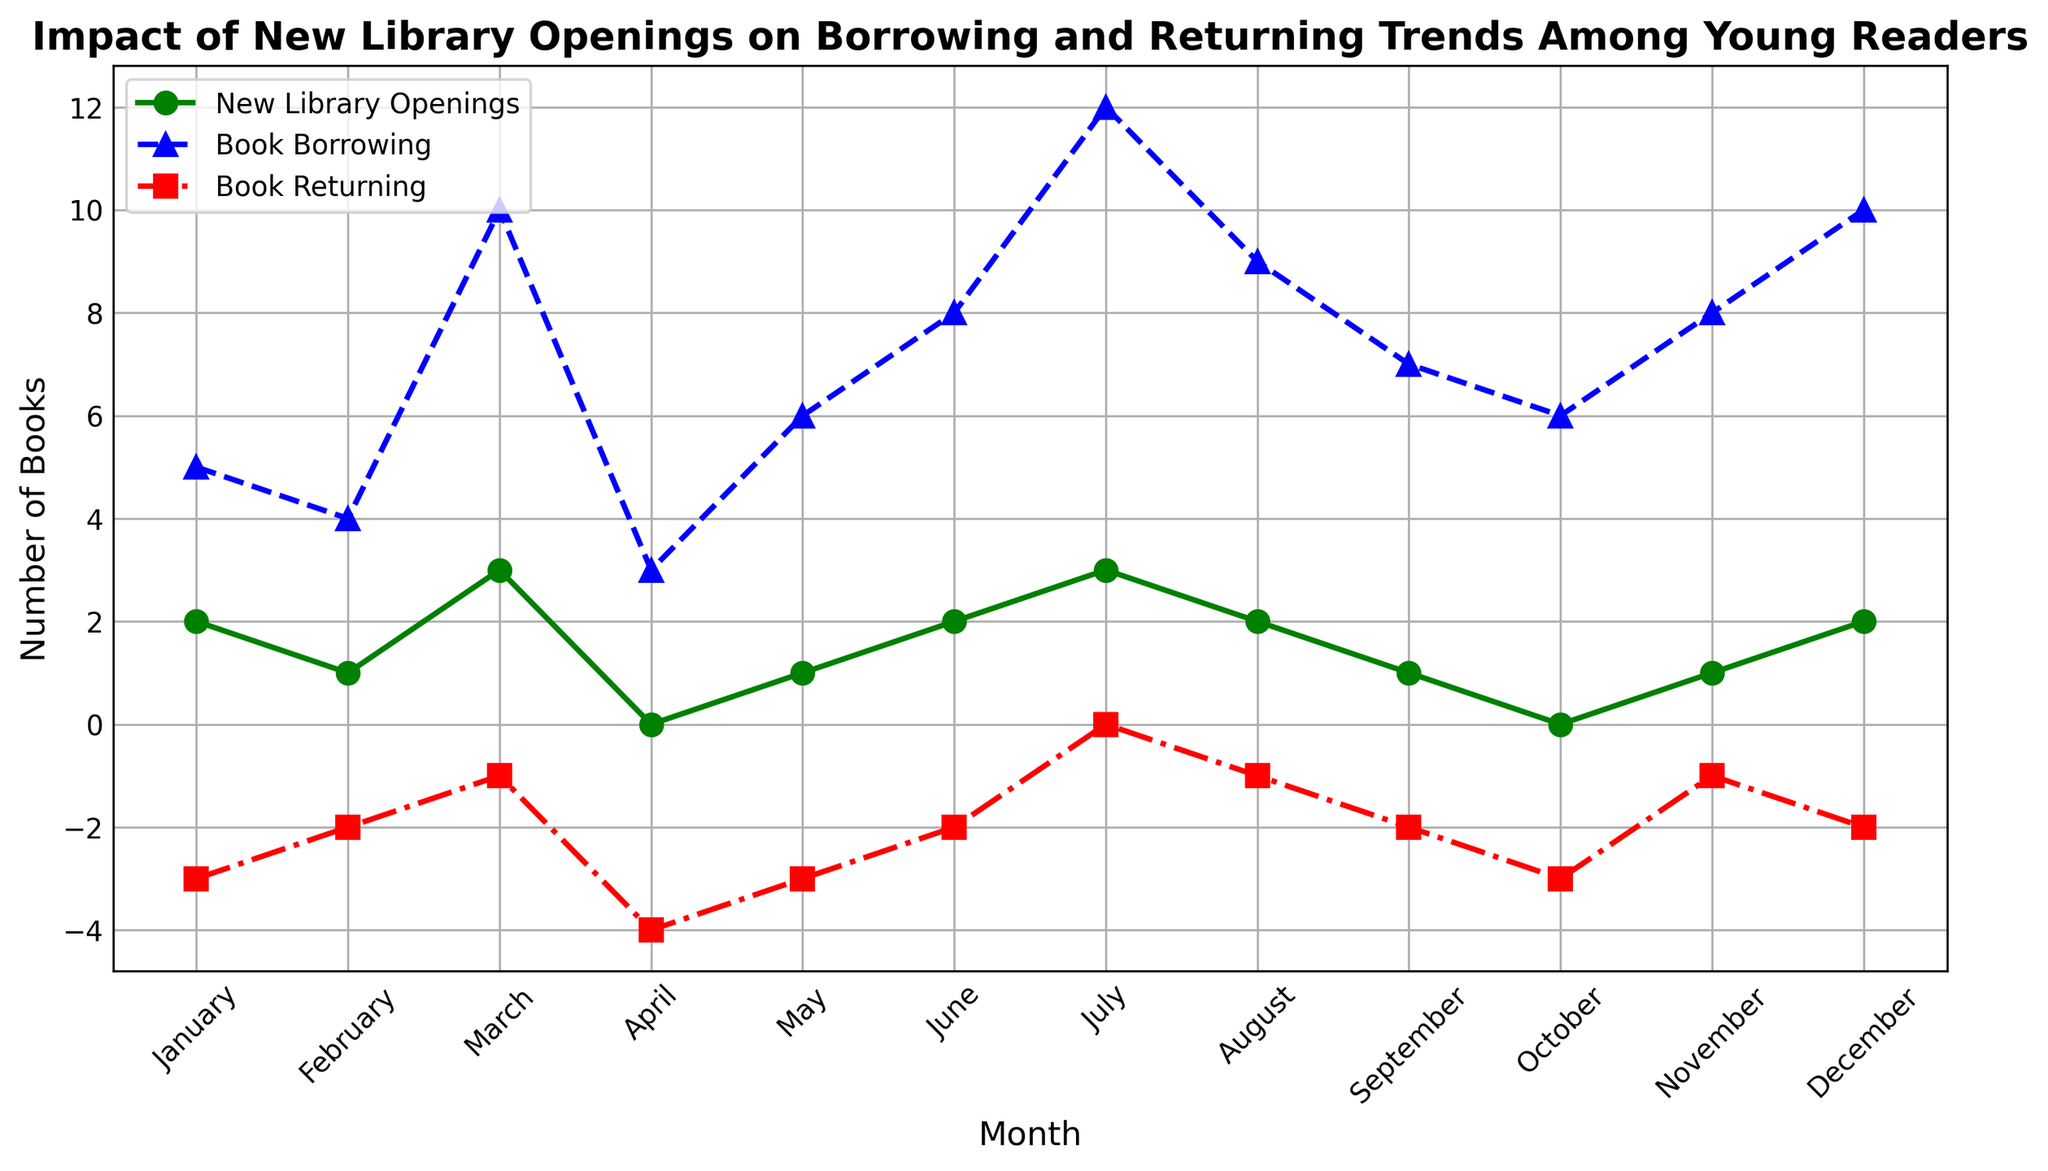What's the pattern of new library openings across the months? The green line with circle markers on the plot represents new library openings. By observing this line, we notice fluctuations with the highest peaks in March, July, and December where there were 3 new openings in each of those months. The lowest point, with no new openings, appears in April and October.
Answer: The pattern shows fluctuations with peaks in March, July, and December, and no openings in April and October Which month had the highest book borrowing among young readers, and how many books were borrowed? Referring to the blue line with triangle markers, we find that the month's peak is the highest in July with a value of 12 book borrowings.
Answer: July, 12 books How do book borrowings and book returns correlate in July? In July, the book borrowing (blue line) reaches its highest peak at 12, while the book returning (red line) is at its neutral point (0). This suggests that while a lot of books were borrowed, none were returned in July.
Answer: High borrowing with no returns in July, 12 borrowed and 0 returned What is the trend for book returning from January to December? The red line with square markers indicates book returning trends. The values are mostly negative, ranging from -4 to 0, indicating more net returns or fewer books being returned each month, with the lowest returning in April and the exact neutral return in July.
Answer: Mostly negative, lowest in April (-4) and neutral in July (0) In which months are the book borrowing and book returning trends exactly opposite? We observe the blue and red lines: in months where borrowing is high, like July (12 borrowed, 0 returned), and months like April (3 borrowed, -4 returned), they are opposite in direction - one peaking up while the other peaking down.
Answer: July (12 borrowed, 0 returned) and April (3 borrowed, -4 returned) Compare the maximum value of new library openings with the maximum value of book borrowings. Observing the peaks of the green and blue lines, the maximum value of new library openings is 3 (March, July, December), while the highest peak for book borrowings is 12 (July).
Answer: 3 for new library openings, 12 for book borrowings What is the average number of new library openings over the entire year? Adding the values from the green line: 2 (Jan) + 1 (Feb) + 3 (Mar) + 0 (Apr) + 1 (May) + 2 (Jun) + 3 (Jul) + 2 (Aug) + 1 (Sep) + 0 (Oct) + 1 (Nov) + 2 (Dec) = 18. There are 12 months, so the average is 18/12 = 1.5.
Answer: 1.5 During which month(s) do book borrowings exceed the number of new library openings by the greatest margin? To find this, we look at the difference in values between the blue and green lines. In July, borrowings (12) exceed new openings (3) by 9, which is the greatest margin when compared to other months.
Answer: July, by 9 Which month has the smallest net book return, and what is the net value? Net return is indicated by the lowest point on the red line. In April, book returns hit -4, which is the smallest net return over the entire year.
Answer: April, -4 Compare the borrowing and returning trends in November. In November, the values on the blue and red lines are 8 for borrowing and -1 for returning. Borrowing is significantly higher than returning, suggesting more books were borrowed than returned.
Answer: November, 8 borrowed and -1 returned 